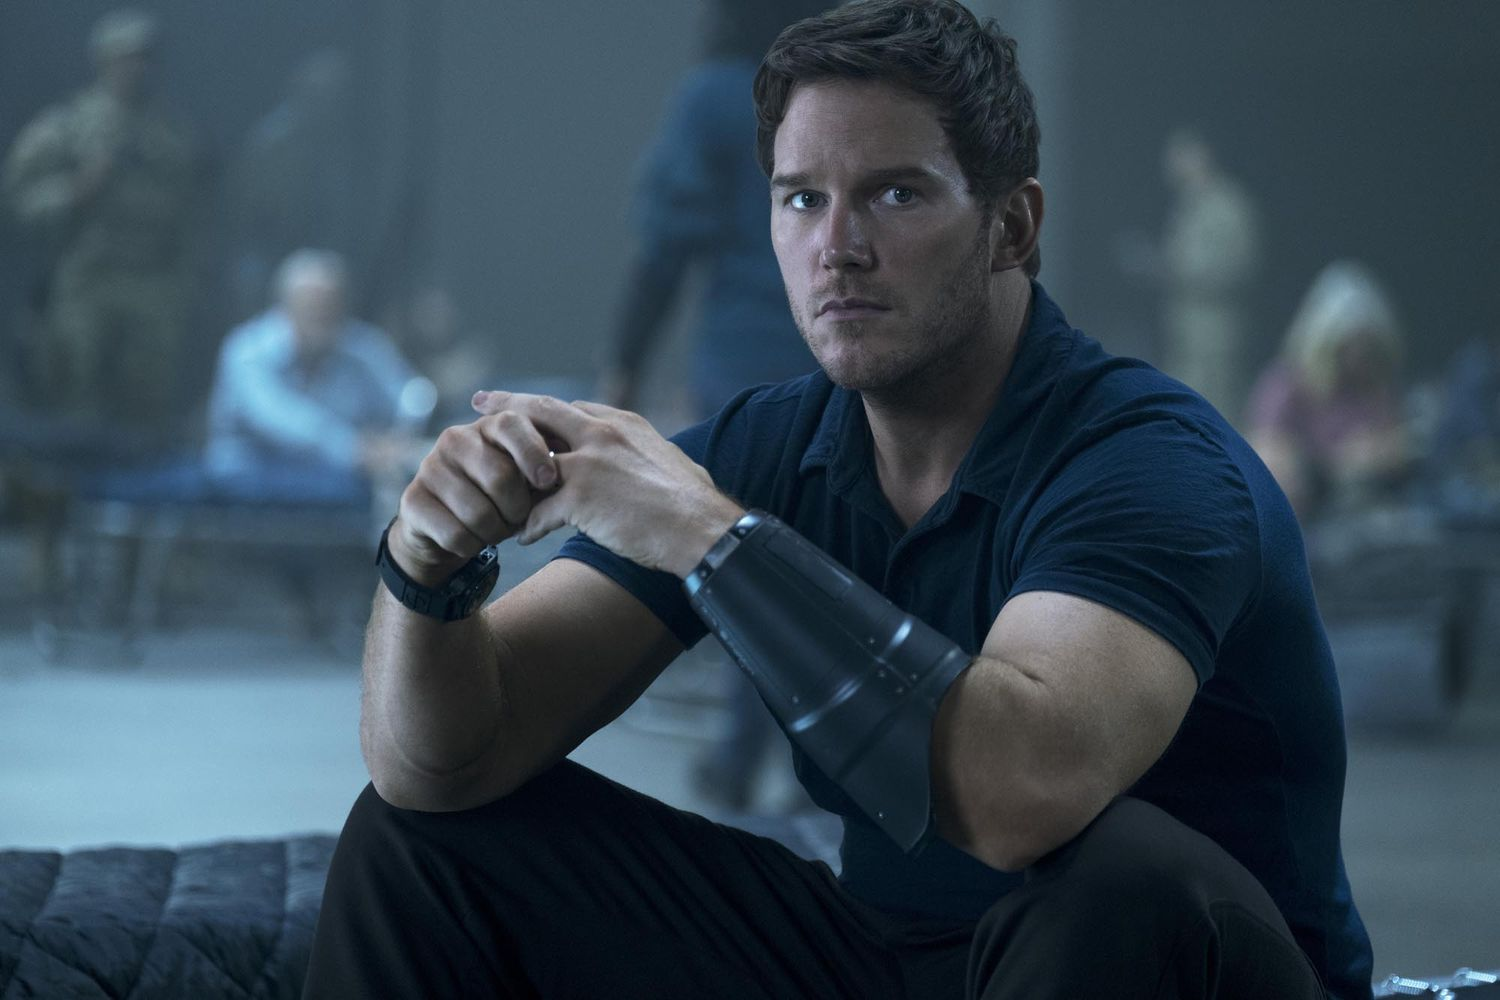Could this scene be a flashback? If so, what might it signify? If this scene is a flashback, it might signify a pivotal moment in the character's past. Perhaps it was a decisive mission that shaped his current outlook or career. The somber yet determined expression suggests a formative experience, one filled with critical decisions and impactful outcomes that resonate with the character's present motivations and actions. 